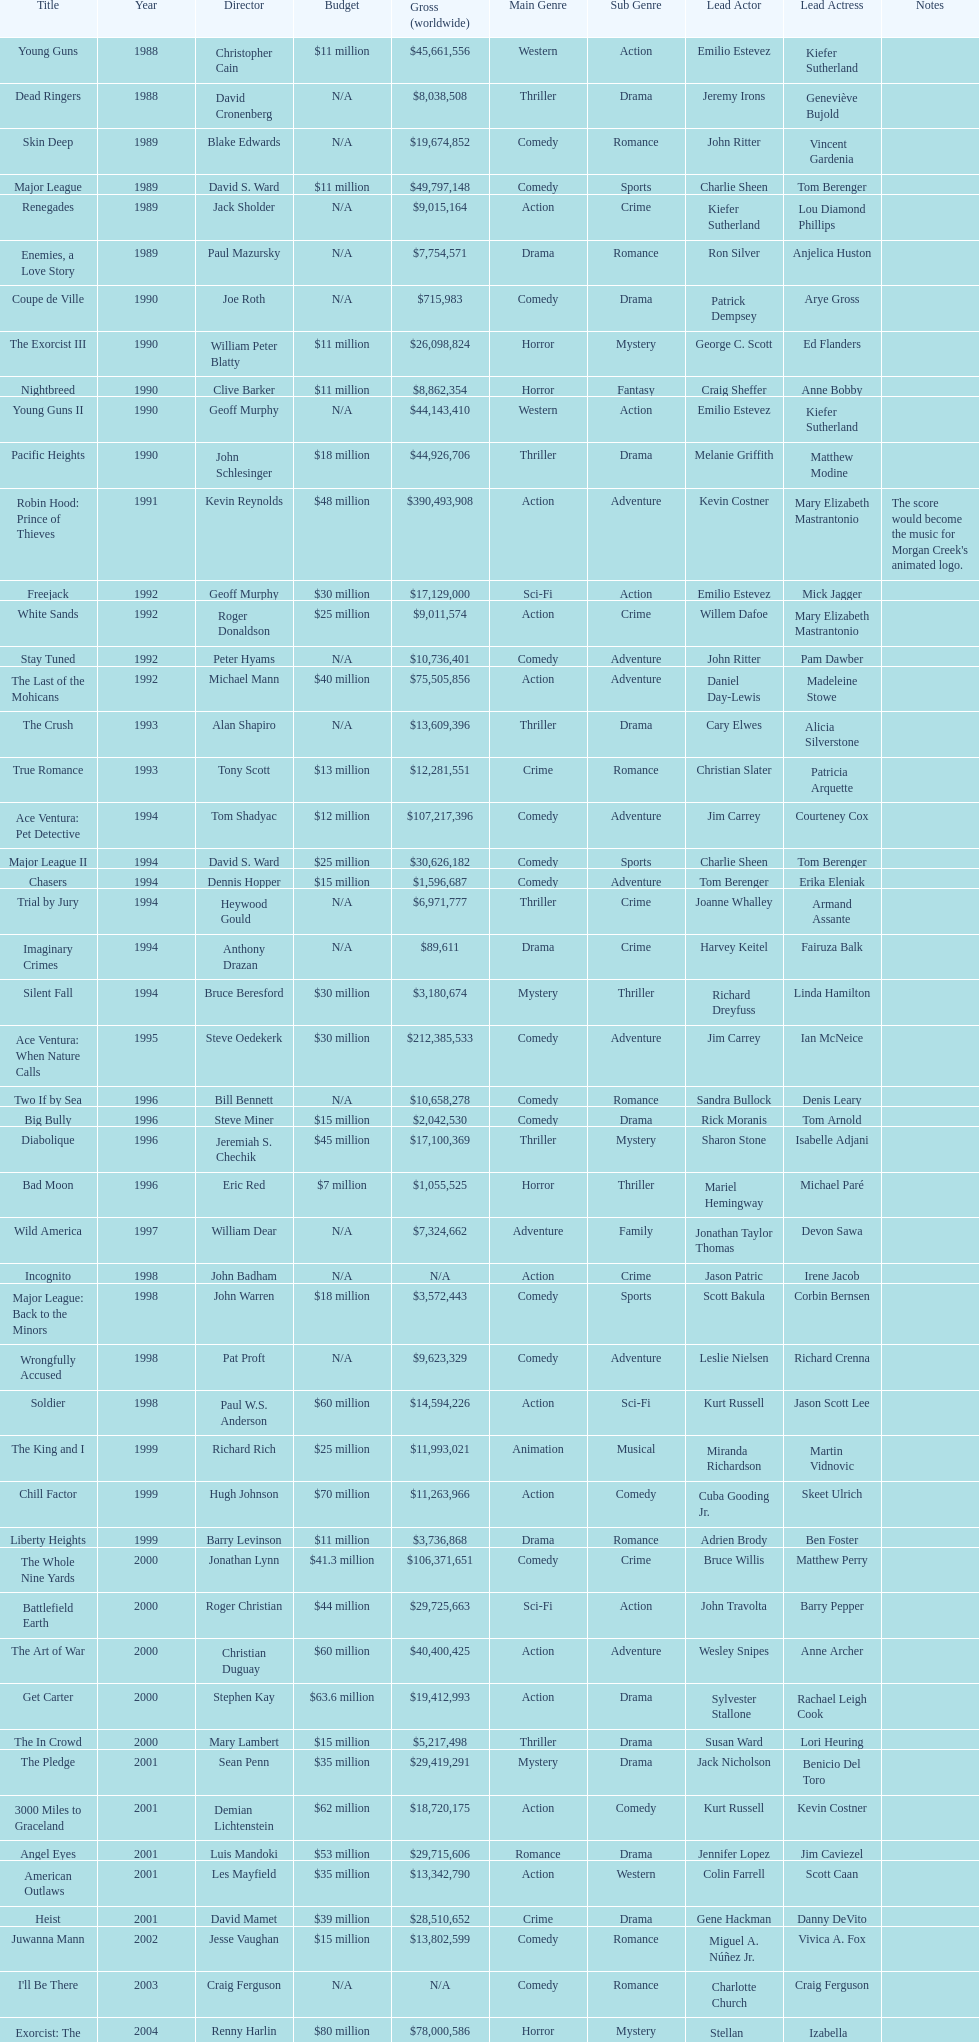How many films were there in 1990? 5. 